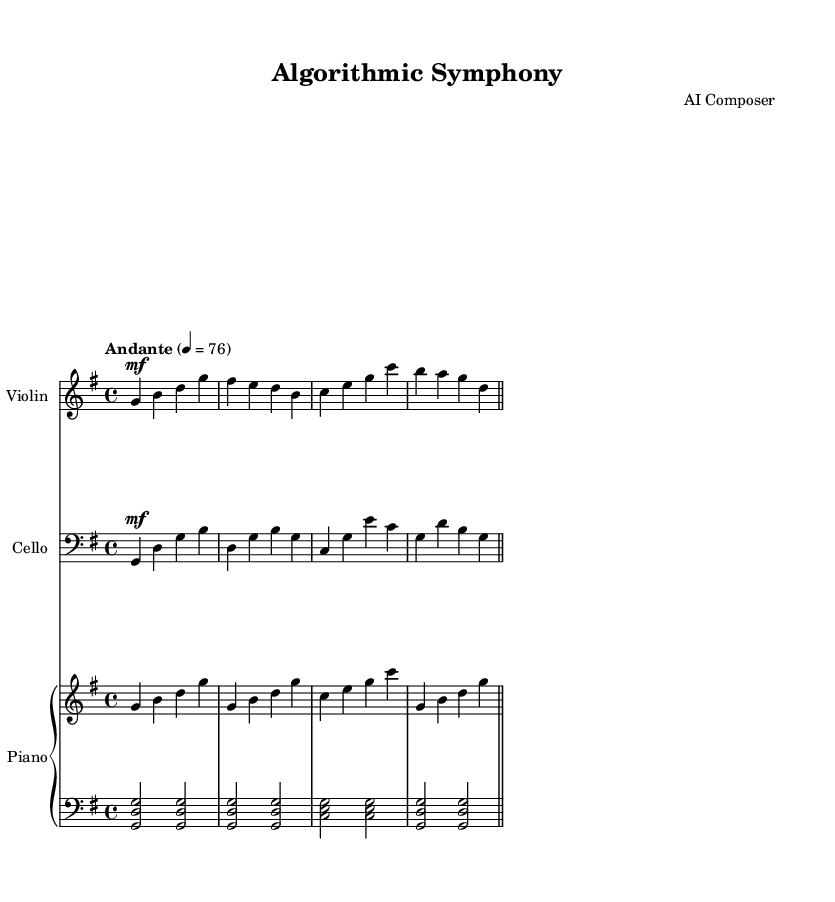What is the key signature of this music? The key signature is indicated at the beginning of the score, with one sharp (F#), which signifies that the music is in G major.
Answer: G major What is the time signature? The time signature is found at the beginning of the score, represented as "4/4", meaning there are four beats in each measure and the quarter note gets one beat.
Answer: 4/4 What is the tempo marking? The tempo marking, found at the start of the piece, indicates the speed of the music and is specified as "Andante," which typically suggests a moderate pace.
Answer: Andante Which instruments are used in this chamber music? The instruments are listed above their respective staves in the score. The score includes violin, cello, and piano.
Answer: Violin, cello, piano How many measures are in the violin part? By counting the measures from the end of the part, we see there are four measures in the violin part provided.
Answer: 4 What dynamic marking is used in the cello part? The dynamic marking for the cello part is "mf," indicating that it should be played at a mezzo-forte dynamic level, which is moderately loud.
Answer: mf What is the right hand playing in the piano part? The right hand of the piano part plays a series of quarter notes: g, b, d, g, corresponding to the G major chord structure commonly found in the piece.
Answer: G major chord 